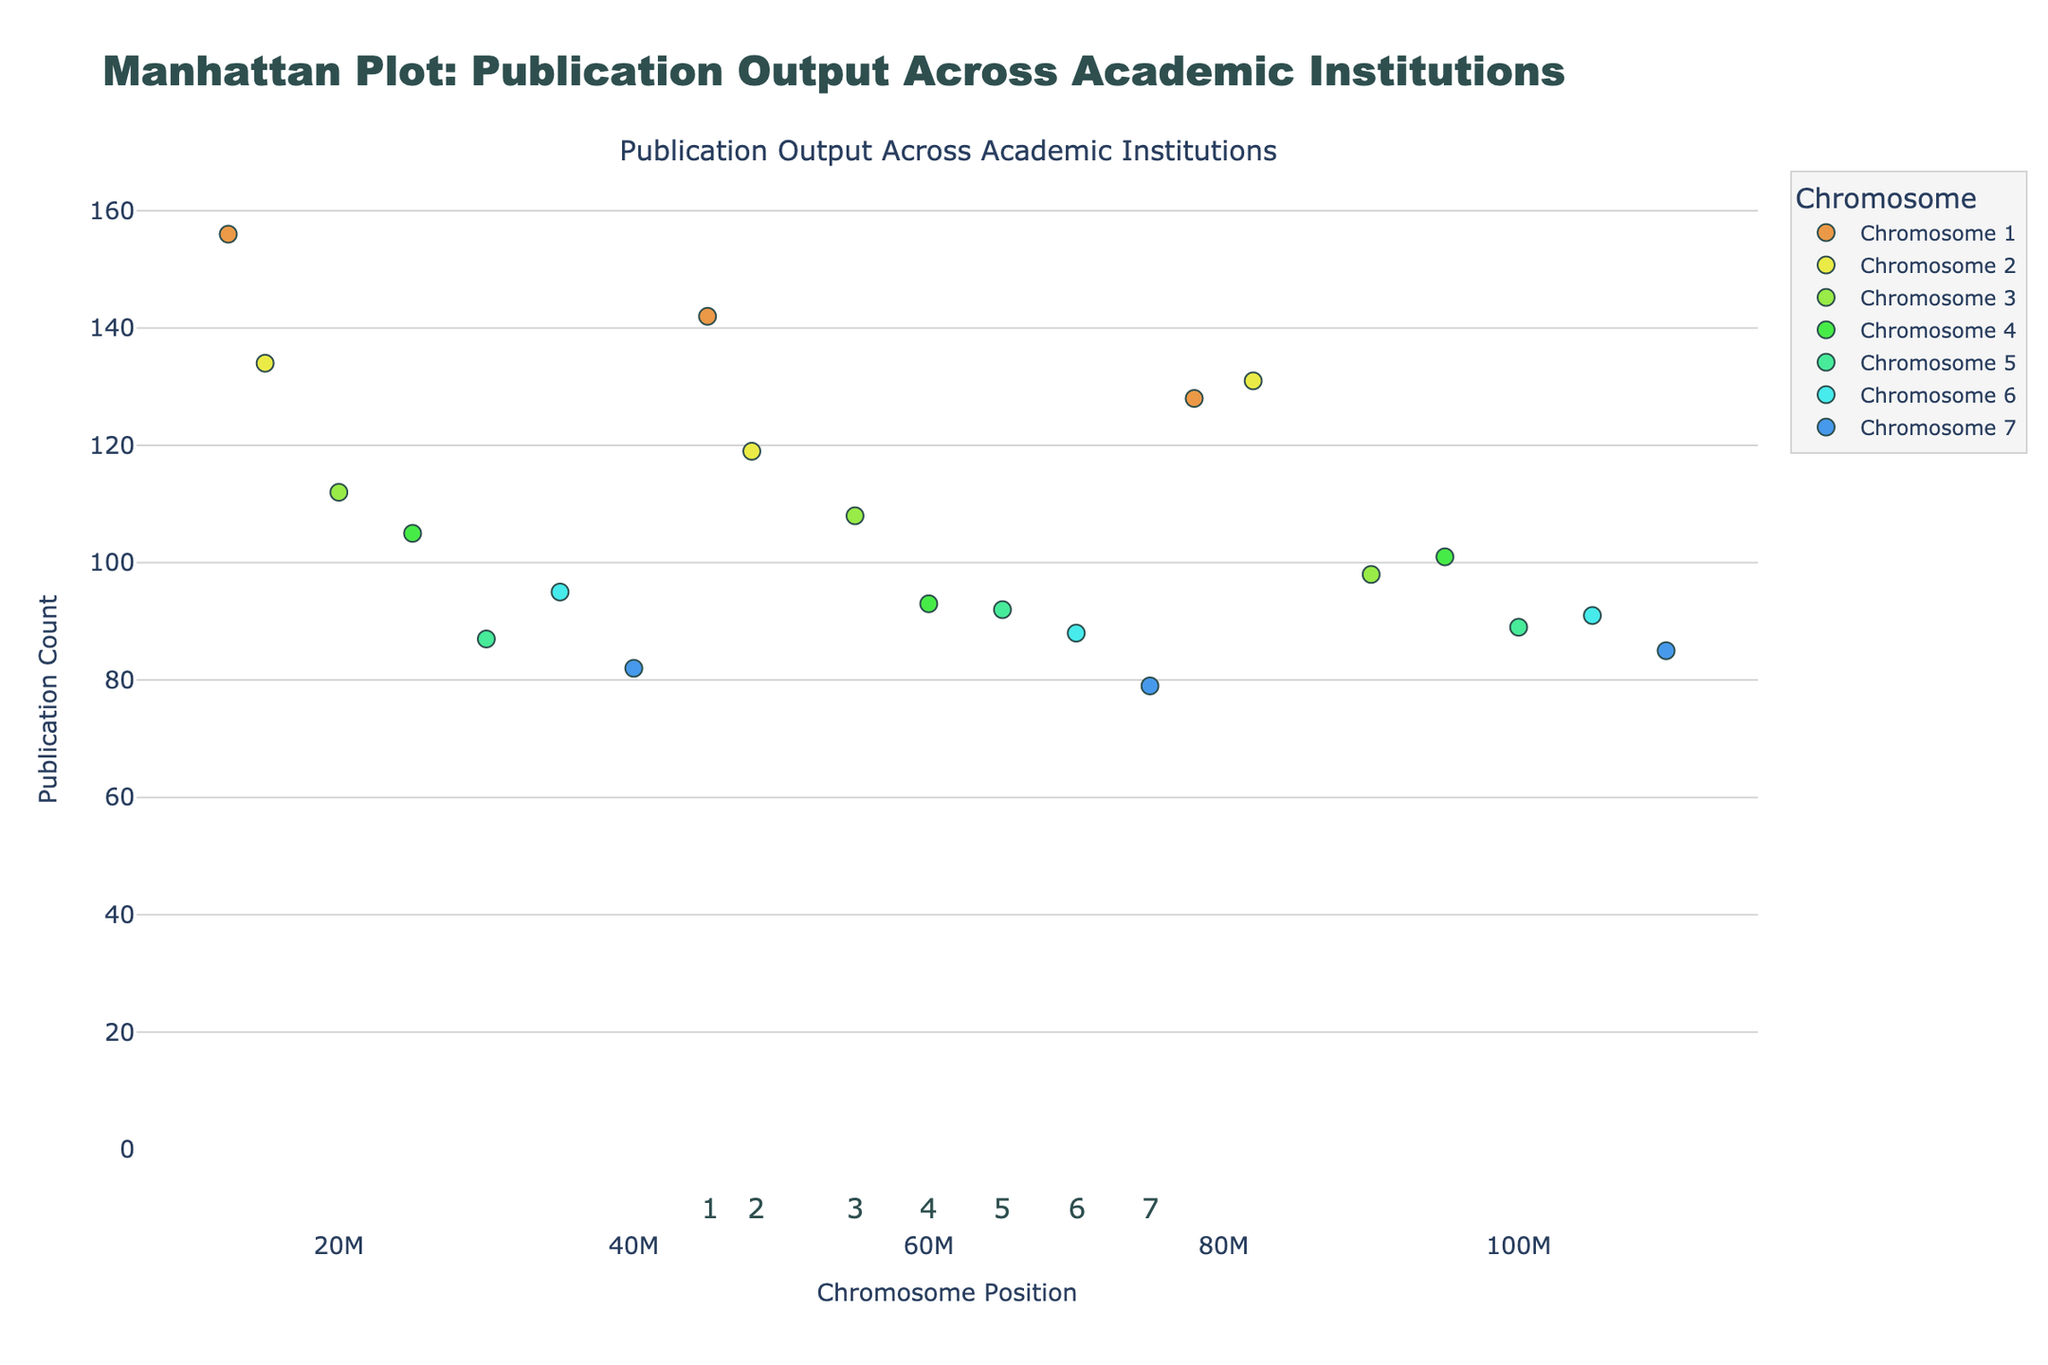What's the title of the plot? The title of the plot is prominently displayed at the top. It reads "Manhattan Plot: Publication Output Across Academic Institutions," which indicates the content and context of the data being represented.
Answer: Manhattan Plot: Publication Output Across Academic Institutions Which institution has the highest publication count? Observing the y-axis and the markers on the plot, the highest point on the publication count axis corresponds to "Harvard University" with 156 publications.
Answer: Harvard University How many academic institutions have a publication count above 120? By examining the y-axis and identifying markers above the 120 mark, there are six institutions: Harvard University, Stanford University, MIT, University of Oxford, University of Cambridge, and Columbia University.
Answer: 6 Which chromosome has the widest range of positions covered? By comparing the x-axis spans for each chromosome, Chromosome 7 covers positions from 40,000,000 to 110,000,000, which is the widest range among all chromosomes.
Answer: Chromosome 7 Compare the publication counts of Stanford University and UC Berkeley. Which one is higher and by how much? Stanford University has 142 publications, while UC Berkeley has 119. The difference is calculated as 142 - 119.
Answer: Stanford University by 23 What is the average publication count of institutions on Chromosome 4? The institutions on Chromosome 4 are Columbia University, University of Chicago, and University of Pennsylvania with publication counts of 105, 93, and 101, respectively. The average is calculated as (105 + 93 + 101) / 3.
Answer: 99.67 Which institution on Chromosome 5 has the lowest publication count, and what is that count? By analyzing the markers on Chromosome 5, Caltech has the lowest publication count with 87 publications.
Answer: Caltech with 87 publications What is the publication count difference between the institution with the highest and the lowest count on Chromosome 6? On Chromosome 6, UCLA has the highest count with 95 publications, and University of Michigan has the lowest with 88. The difference is 95 - 88.
Answer: 7 How many data points are there for Chromosome 3, and what are their publication counts? Chromosome 3 has three data points: Johns Hopkins University with 112, Yale University with 108, and Princeton University with 98.
Answer: 3 (112, 108, 98) Does any chromosome appear to have a cluster of high publication counts in a specific position range? Chromosome 1 showcases a cluster of high publication counts with Harvard University, Stanford University, and MIT having counts of 156, 142, and 128, respectively, clustered at positions 12,500,000 to 78,000,000.
Answer: Yes, Chromosome 1 